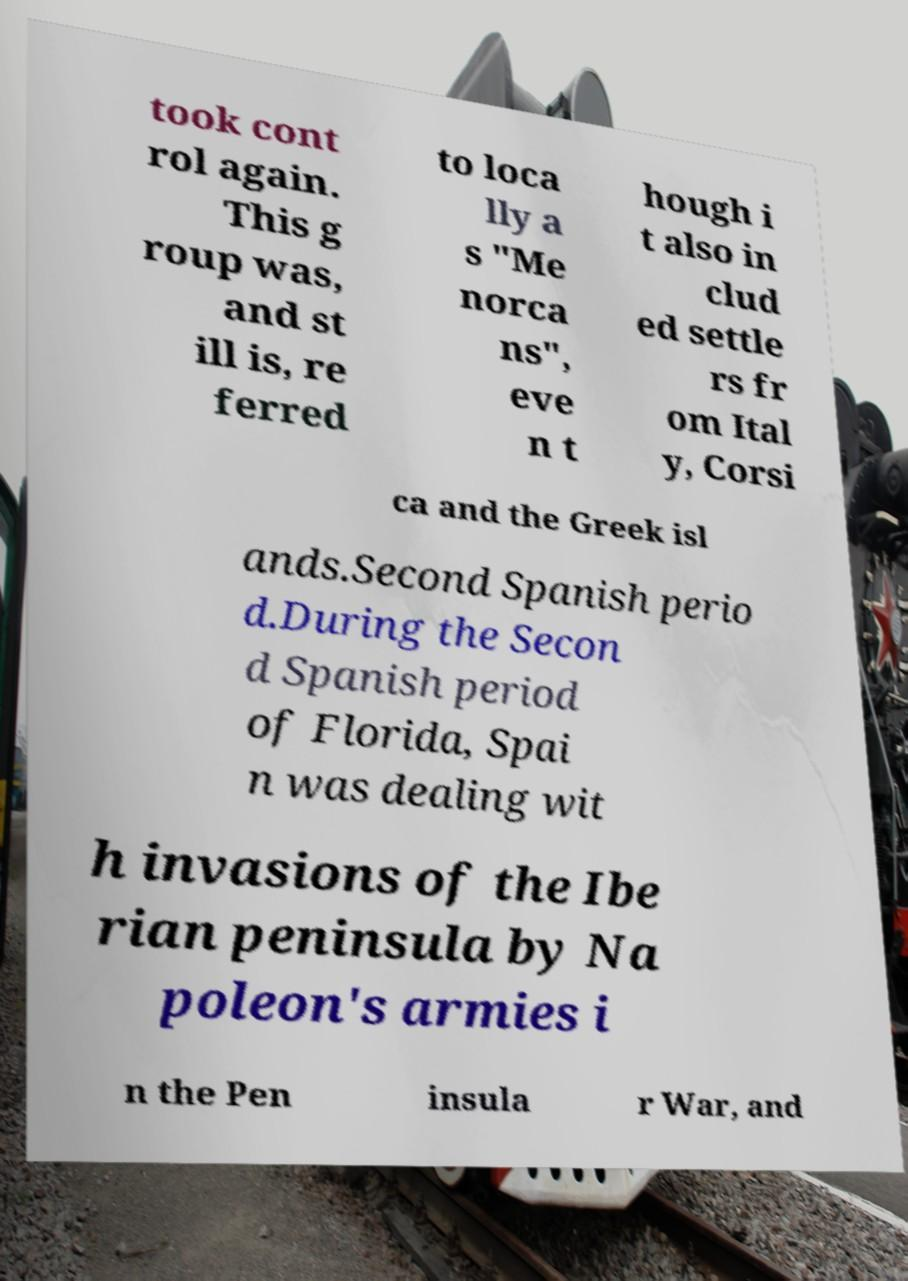For documentation purposes, I need the text within this image transcribed. Could you provide that? took cont rol again. This g roup was, and st ill is, re ferred to loca lly a s "Me norca ns", eve n t hough i t also in clud ed settle rs fr om Ital y, Corsi ca and the Greek isl ands.Second Spanish perio d.During the Secon d Spanish period of Florida, Spai n was dealing wit h invasions of the Ibe rian peninsula by Na poleon's armies i n the Pen insula r War, and 